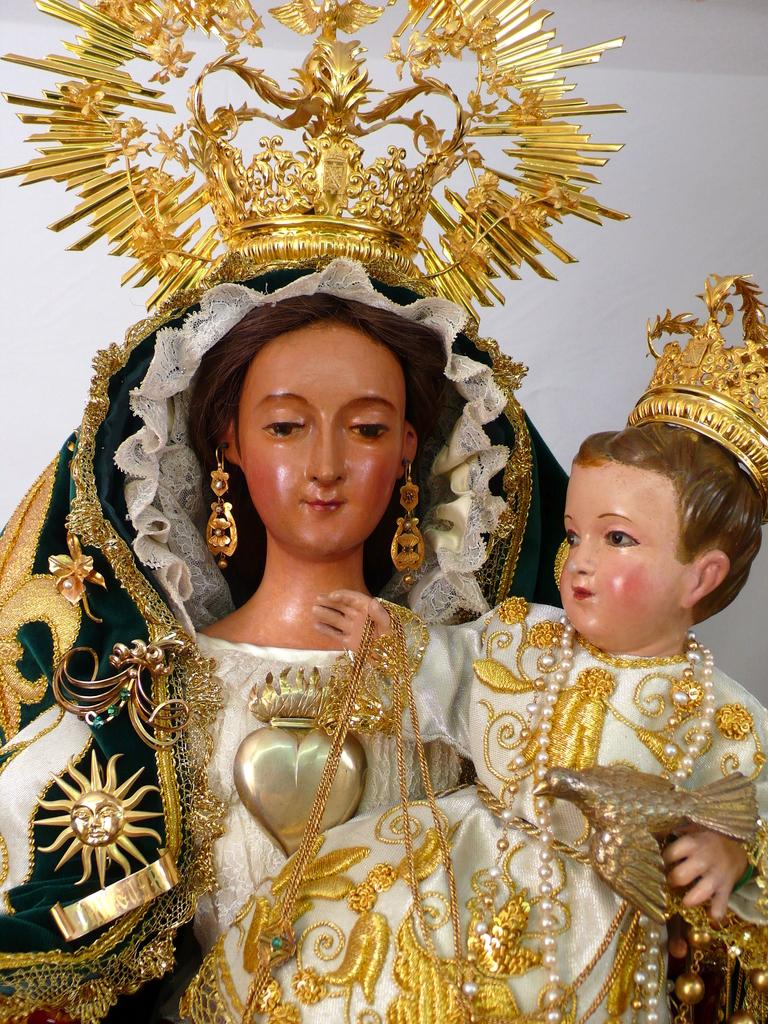What subjects are depicted in the statues in the image? There are statues of a woman and a child in the image. What are the statues wearing on their heads? The statues are wearing crowns. What other accessories are the statues wearing? The statues are wearing jewelry. What can be seen behind the statues in the image? There is a wall visible on the backside of the image. How many girls are playing quietly with the jewelry in the image? There are no girls present in the image, and the jewelry is worn by the statues, not played with. 